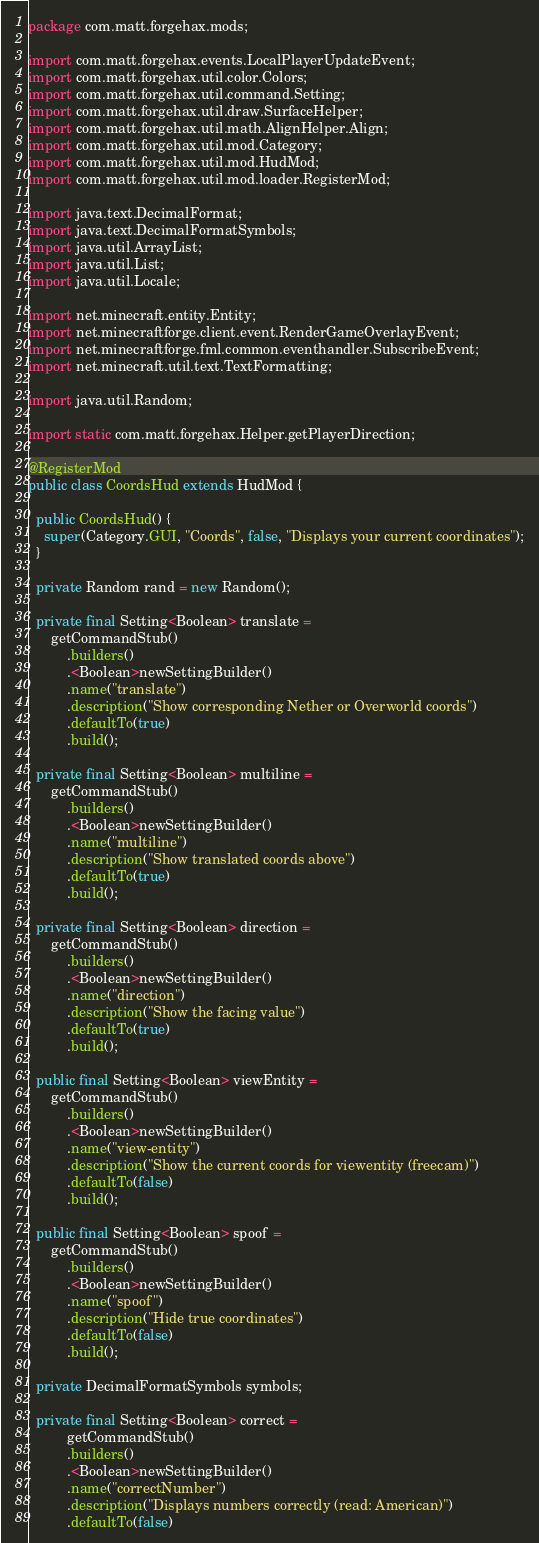<code> <loc_0><loc_0><loc_500><loc_500><_Java_>package com.matt.forgehax.mods;

import com.matt.forgehax.events.LocalPlayerUpdateEvent;
import com.matt.forgehax.util.color.Colors;
import com.matt.forgehax.util.command.Setting;
import com.matt.forgehax.util.draw.SurfaceHelper;
import com.matt.forgehax.util.math.AlignHelper.Align;
import com.matt.forgehax.util.mod.Category;
import com.matt.forgehax.util.mod.HudMod;
import com.matt.forgehax.util.mod.loader.RegisterMod;

import java.text.DecimalFormat;
import java.text.DecimalFormatSymbols;
import java.util.ArrayList;
import java.util.List;
import java.util.Locale;

import net.minecraft.entity.Entity;
import net.minecraftforge.client.event.RenderGameOverlayEvent;
import net.minecraftforge.fml.common.eventhandler.SubscribeEvent;
import net.minecraft.util.text.TextFormatting;

import java.util.Random;

import static com.matt.forgehax.Helper.getPlayerDirection;

@RegisterMod
public class CoordsHud extends HudMod {

  public CoordsHud() {
    super(Category.GUI, "Coords", false, "Displays your current coordinates");
  }

  private Random rand = new Random();

  private final Setting<Boolean> translate =
      getCommandStub()
          .builders()
          .<Boolean>newSettingBuilder()
          .name("translate")
          .description("Show corresponding Nether or Overworld coords")
          .defaultTo(true)
          .build();

  private final Setting<Boolean> multiline =
      getCommandStub()
          .builders()
          .<Boolean>newSettingBuilder()
          .name("multiline")
          .description("Show translated coords above")
          .defaultTo(true)
          .build();

  private final Setting<Boolean> direction =
      getCommandStub()
          .builders()
          .<Boolean>newSettingBuilder()
          .name("direction")
          .description("Show the facing value")
          .defaultTo(true)
          .build();

  public final Setting<Boolean> viewEntity =
      getCommandStub()
          .builders()
          .<Boolean>newSettingBuilder()
          .name("view-entity")
          .description("Show the current coords for viewentity (freecam)")
          .defaultTo(false)
          .build();

  public final Setting<Boolean> spoof =
      getCommandStub()
          .builders()
          .<Boolean>newSettingBuilder()
          .name("spoof")
          .description("Hide true coordinates")
          .defaultTo(false)
          .build();
  
  private DecimalFormatSymbols symbols;

  private final Setting<Boolean> correct =
		  getCommandStub()
		  .builders()
		  .<Boolean>newSettingBuilder()
		  .name("correctNumber")
		  .description("Displays numbers correctly (read: American)")
		  .defaultTo(false)</code> 